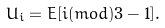Convert formula to latex. <formula><loc_0><loc_0><loc_500><loc_500>U _ { i } = E [ i ( m o d ) 3 - 1 ] .</formula> 